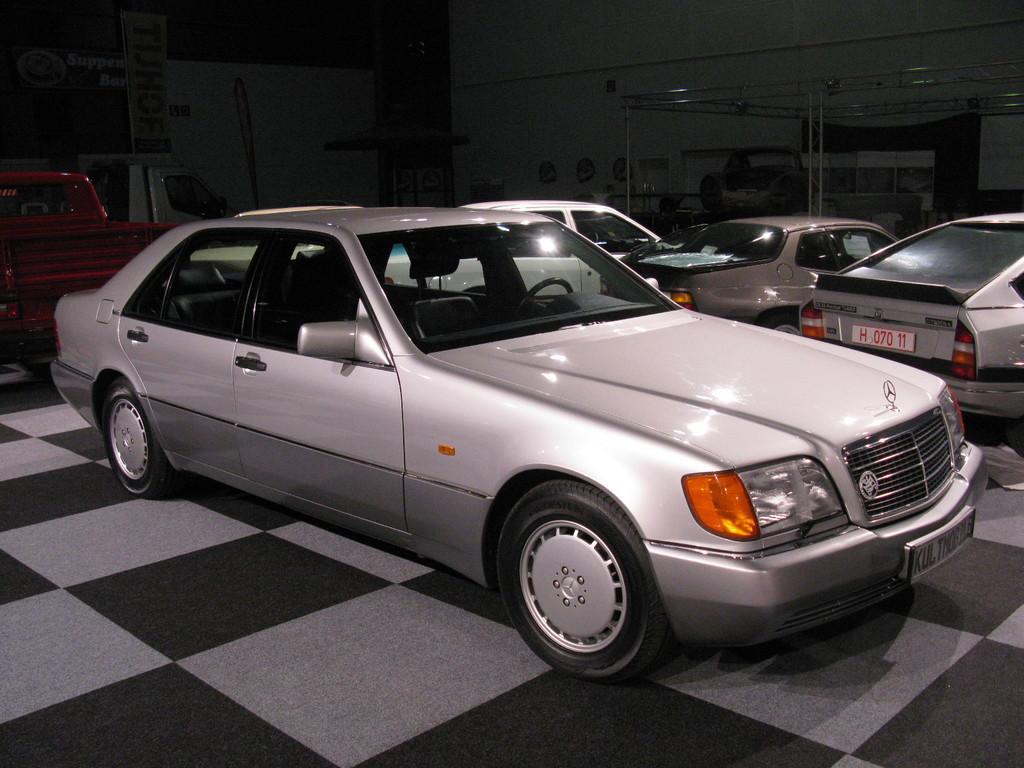In one or two sentences, can you explain what this image depicts? In the center of the image we can see group of vehicles parked on the ground. In the top left corner of the image we can see banners with some text. In the background, we can see an umbrella, metal frames and the wall. 